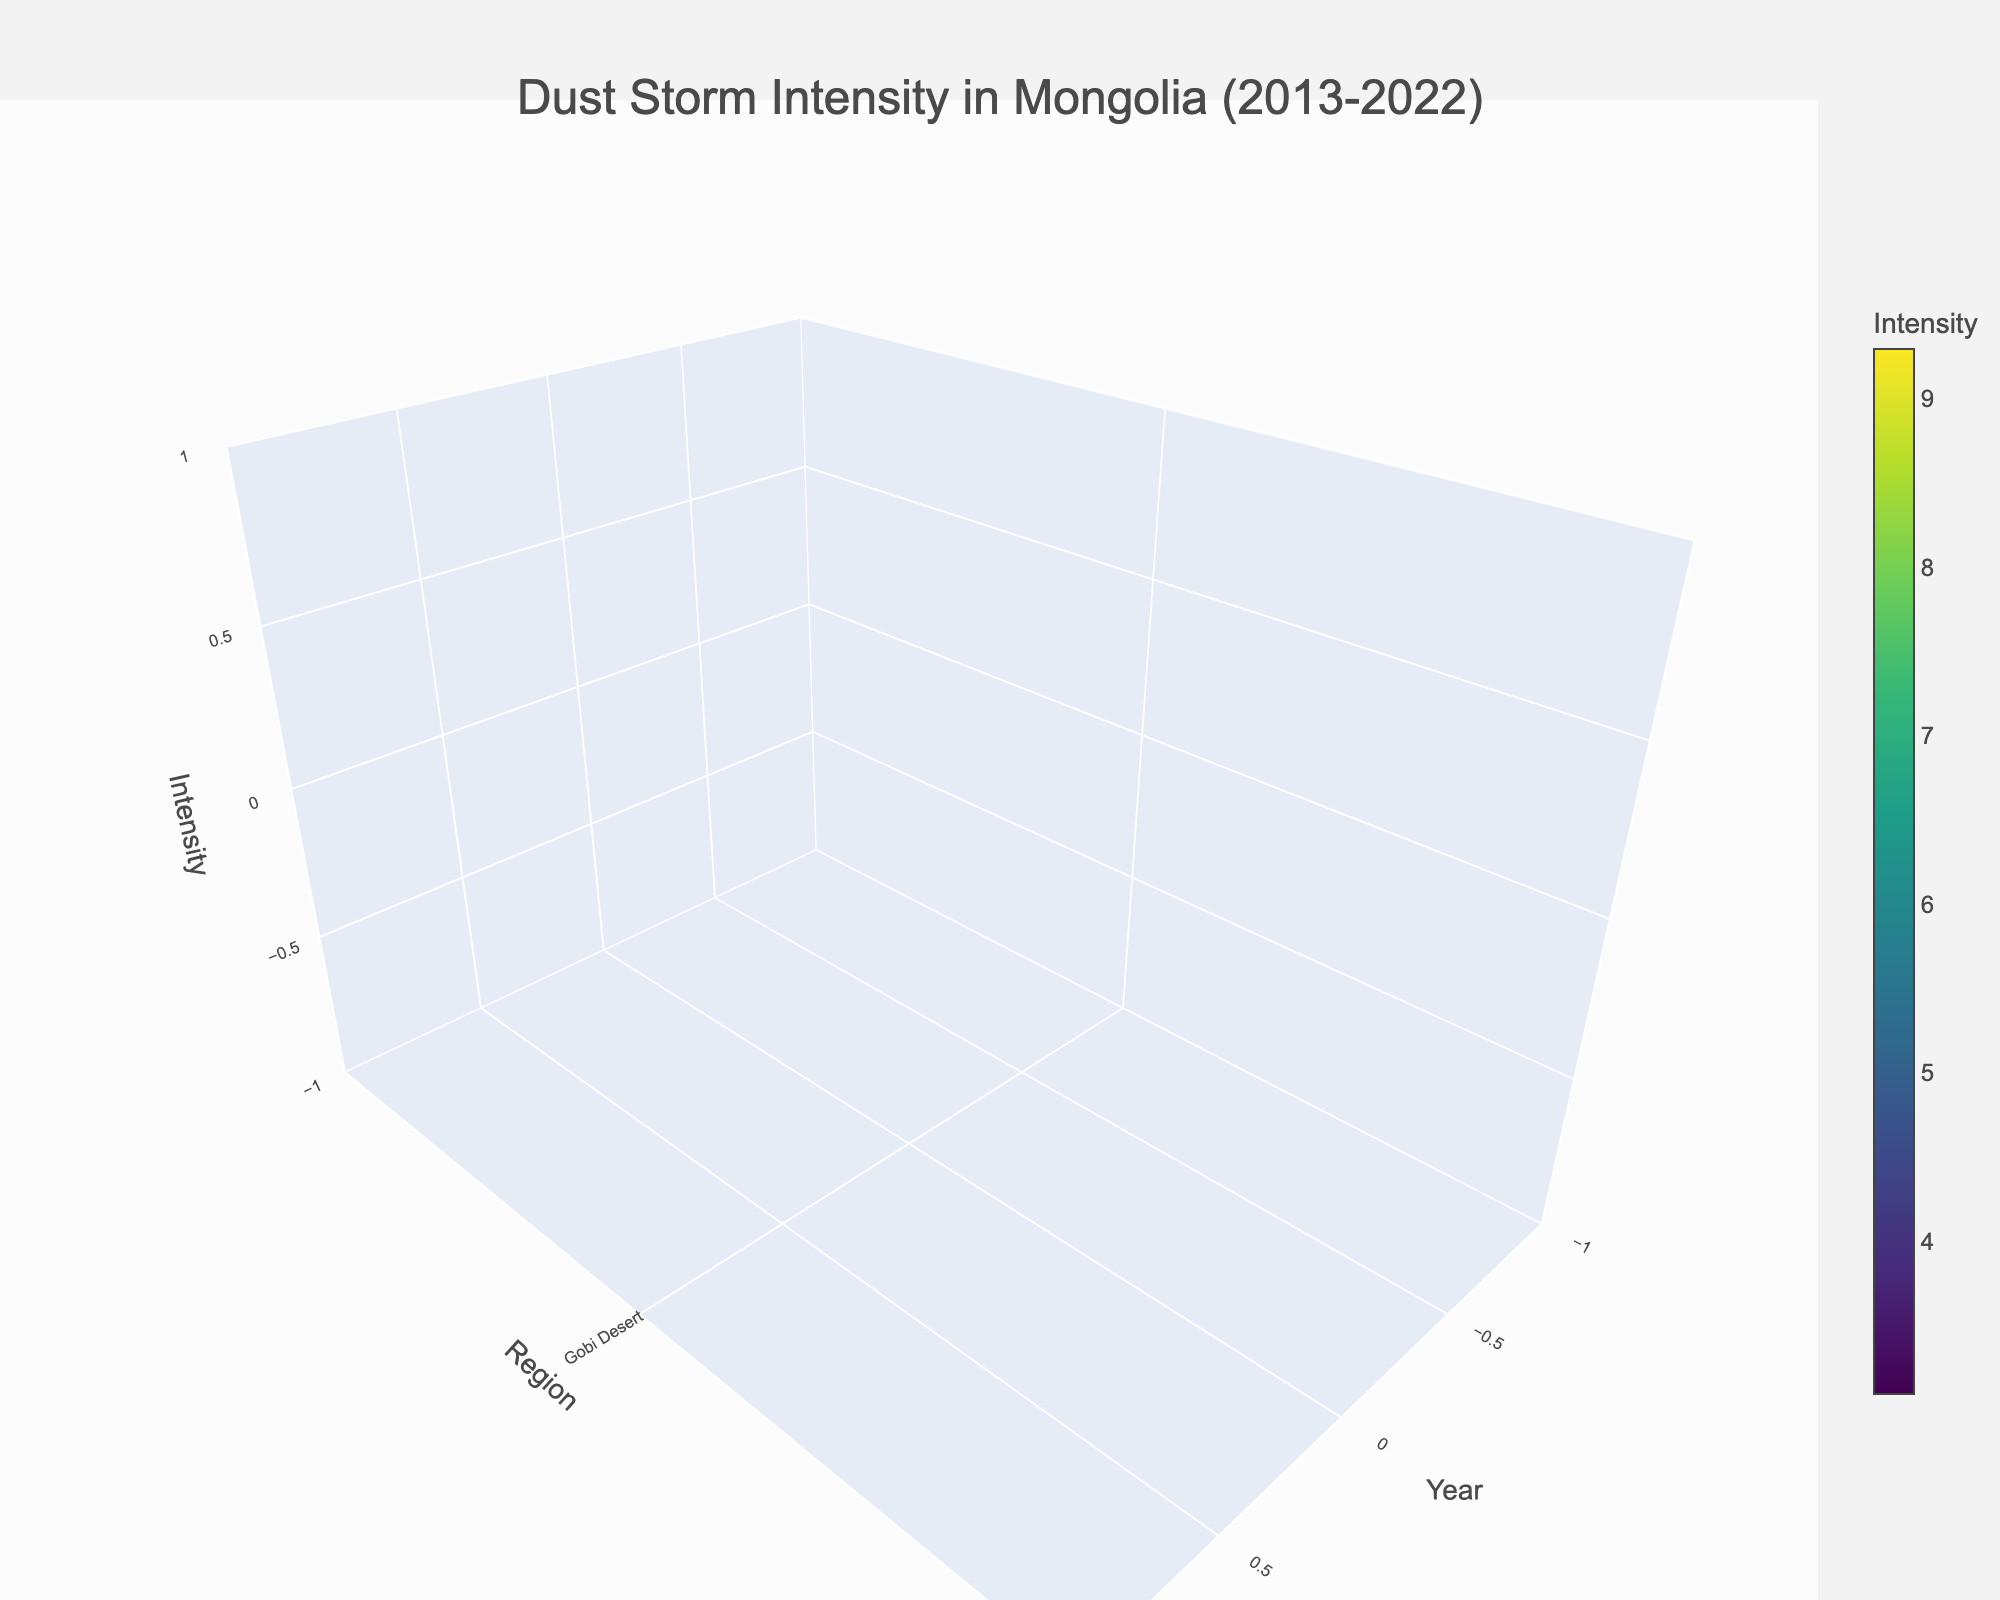What is the title of the figure? The title is displayed at the top center of the figure. It is clearly written above the 3D volume plot in larger font size.
Answer: Dust Storm Intensity in Mongolia (2013-2022) How is the color of the plot related to the intensity? The color represents different levels of intensity, with a colorbar on the side indicating the gradient. Darker colors usually represent higher intensities, and lighter colors represent lower intensities.
Answer: Colorscale from low to high intensity Which region experienced the highest dust storm intensity in 2022? To answer this, look at the 2022 data points across all regions. The highest intensity is indicated by the darkest color or the tallest z-value.
Answer: Gobi Desert What trend is observed in dust storm intensity in the Gobi Desert from 2013 to 2022? To determine the trend, check the intensity values for the Gobi Desert over the years. Notice how the z-values change.
Answer: Increasing Which region had the lowest dust storm frequency in 2013? Check the 2013 data points for all regions to find the one with the lowest frequency value displayed along the z-axis.
Answer: Khangai Mountains How does the dust storm intensity in the Eastern Steppes compare between 2013 and 2019? Compare the z-values (intensity) for the Eastern Steppes in 2013 and 2019. Notice how the z-values and corresponding colors change between these years.
Answer: Higher in 2019 What is the overall trend in dust storm intensity across all regions from 2013 to 2022? Look at the intensity values across all regions for the years 2013 to 2022. Observe if there is a general increase, decrease, or other pattern in intensity.
Answer: Increasing Between the Orkhon Valley and the Altai Mountains, which region had a greater increase in dust storm intensity from 2013 to 2022? Calculate the difference in intensity for both regions from 2013 to 2022. Compare the increase in z-values.
Answer: Orkhon Valley What year had the most significant increase in dust storm intensity in the Gobi Desert? Look for the year-over-year change in intensity values for the Gobi Desert. Identify the largest increase between any two consecutive years.
Answer: 2019 to 2022 How many regions displayed a dust storm intensity higher than 7.0 in 2022? Check the intensity values for all regions in 2022. Count the number of regions with z-values greater than 7.0.
Answer: 3 regions 